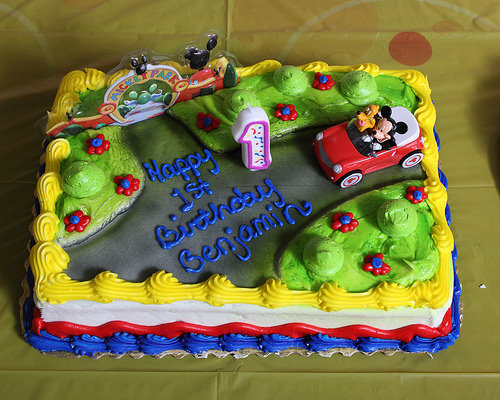<image>
Is the car on the cake? Yes. Looking at the image, I can see the car is positioned on top of the cake, with the cake providing support. 